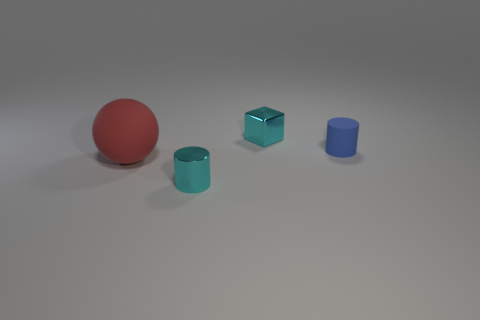Add 3 large gray balls. How many objects exist? 7 Subtract all blocks. How many objects are left? 3 Subtract all purple metallic balls. Subtract all blue rubber cylinders. How many objects are left? 3 Add 1 cylinders. How many cylinders are left? 3 Add 2 large blue matte cylinders. How many large blue matte cylinders exist? 2 Subtract 0 yellow cylinders. How many objects are left? 4 